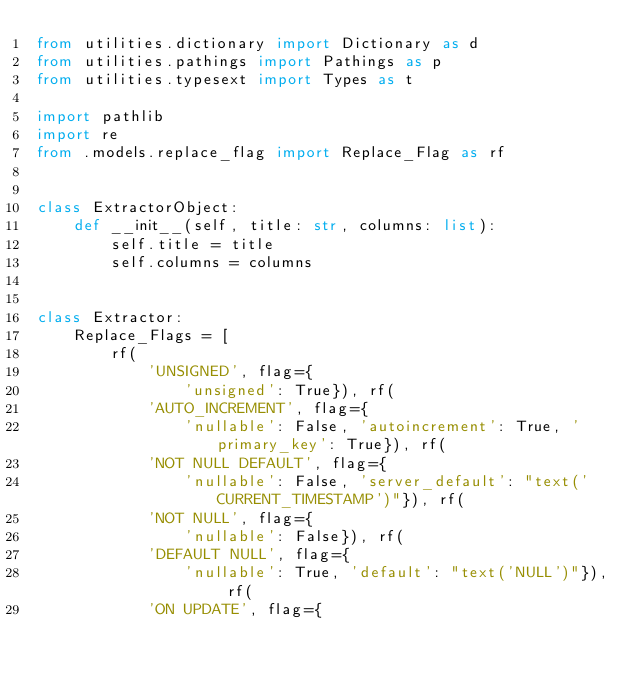Convert code to text. <code><loc_0><loc_0><loc_500><loc_500><_Python_>from utilities.dictionary import Dictionary as d
from utilities.pathings import Pathings as p
from utilities.typesext import Types as t

import pathlib
import re
from .models.replace_flag import Replace_Flag as rf


class ExtractorObject:
    def __init__(self, title: str, columns: list):
        self.title = title
        self.columns = columns


class Extractor:
    Replace_Flags = [
        rf(
            'UNSIGNED', flag={
                'unsigned': True}), rf(
            'AUTO_INCREMENT', flag={
                'nullable': False, 'autoincrement': True, 'primary_key': True}), rf(
            'NOT NULL DEFAULT', flag={
                'nullable': False, 'server_default': "text('CURRENT_TIMESTAMP')"}), rf(
            'NOT NULL', flag={
                'nullable': False}), rf(
            'DEFAULT NULL', flag={
                'nullable': True, 'default': "text('NULL')"}), rf(
            'ON UPDATE', flag={</code> 